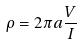Convert formula to latex. <formula><loc_0><loc_0><loc_500><loc_500>\rho = 2 \pi a \frac { V } { I }</formula> 